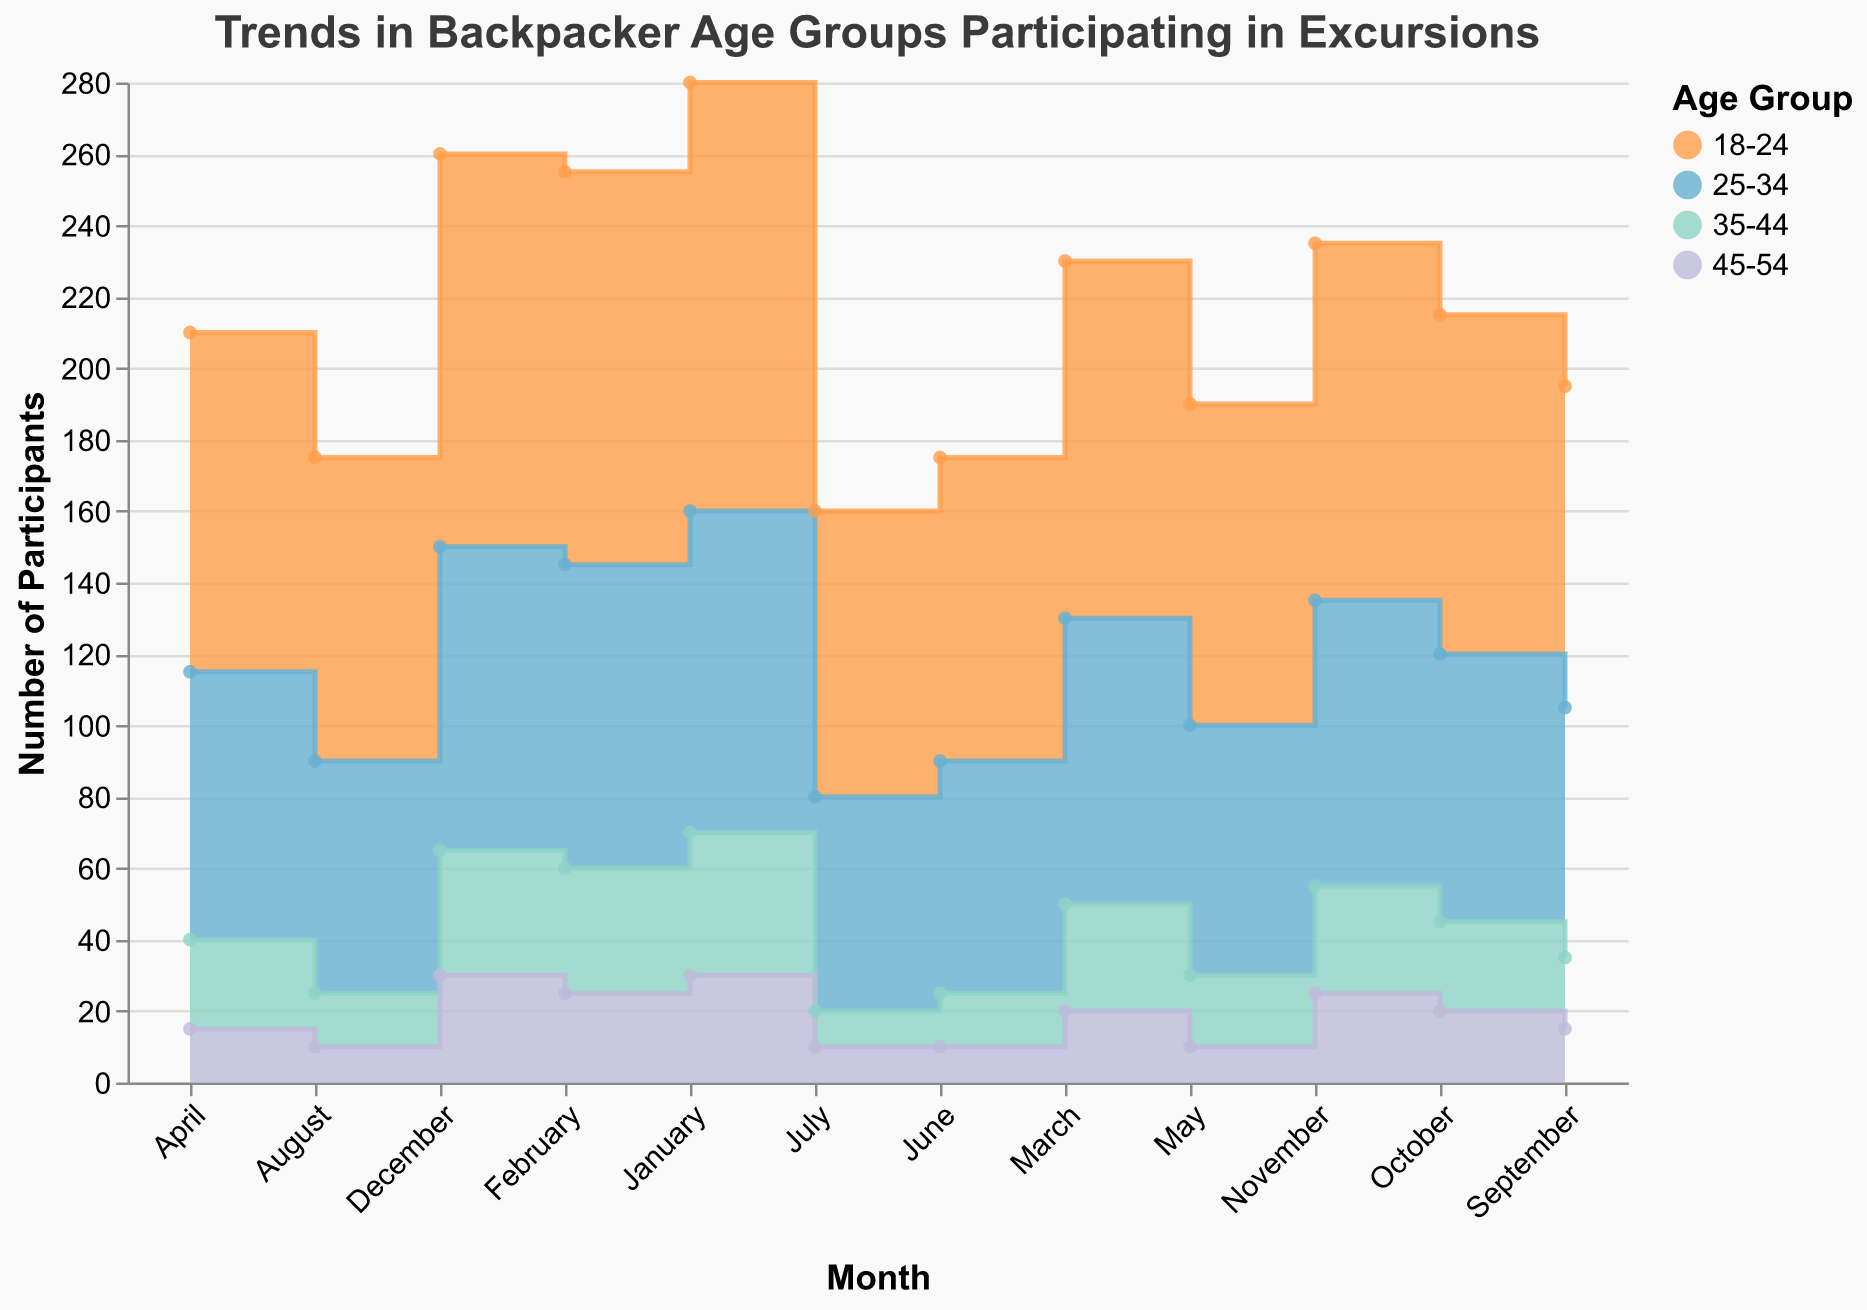What is the month with the highest number of participants in the 18-24 age group? January has 120 participants in the 18-24 age group, which is the highest value across all months for this group.
Answer: January Which age group consistently has the least number of participants across all months? By looking at the stacked areas, the 45-54 age group is consistently at the bottom, indicating the least number of participants across all months.
Answer: 45-54 During which month do the 25-34 and 35-44 age groups have the same number of participants? In June and August, the number of participants in the 35-44 age group is 15 each month, while the number of participants in the 25-34 age group is different each month. No month has the same number.
Answer: None What is the total number of participants in all age groups for December? Summing the values for December: 110 (18-24) + 85 (25-34) + 35 (35-44) + 30 (45-54) = 260.
Answer: 260 Which age group shows the most significant decrease in participation from January to July? The 18-24 age group decreases from 120 in January to 80 in July, a decrease of 40, which is the most significant among the age groups.
Answer: 18-24 During which months does the 25-34 age group have more participants than the 18-24 age group? By comparing the areas, the 18-24 age group always has more participants than the 25-34 age group, so no months match this criteria.
Answer: None Which month sees the largest increase in total participation compared to the previous month? Comparing adjacent months, the total increases most significantly from June to July, with an increase in several age groups. However, upon closer inspection, September to October shows a rise of +10 (15 participants in June to 25 in October).
Answer: September to October How does the participation trend for the 35-44 age group change from February to May? In February, there are 35 participants, and this number decreases steadily to 20 by May.
Answer: Steady decrease What are the average number of participants in the 25-34 age group for the first and second halves of the year? For the first half, average: (90 + 85 + 80 + 75 + 70 + 65) / 6 = 77.5. For the second half, average: (60 + 65 + 70 + 75 + 80 + 85) / 6 = 72.5.
Answer: 77.5 (first half), 72.5 (second half) What is the ratio of participants in the 18-24 age group in January to those in June? The number of participants in January (120) divided by the number in June (85) gives a ratio of approximately 1.41.
Answer: 1.41 